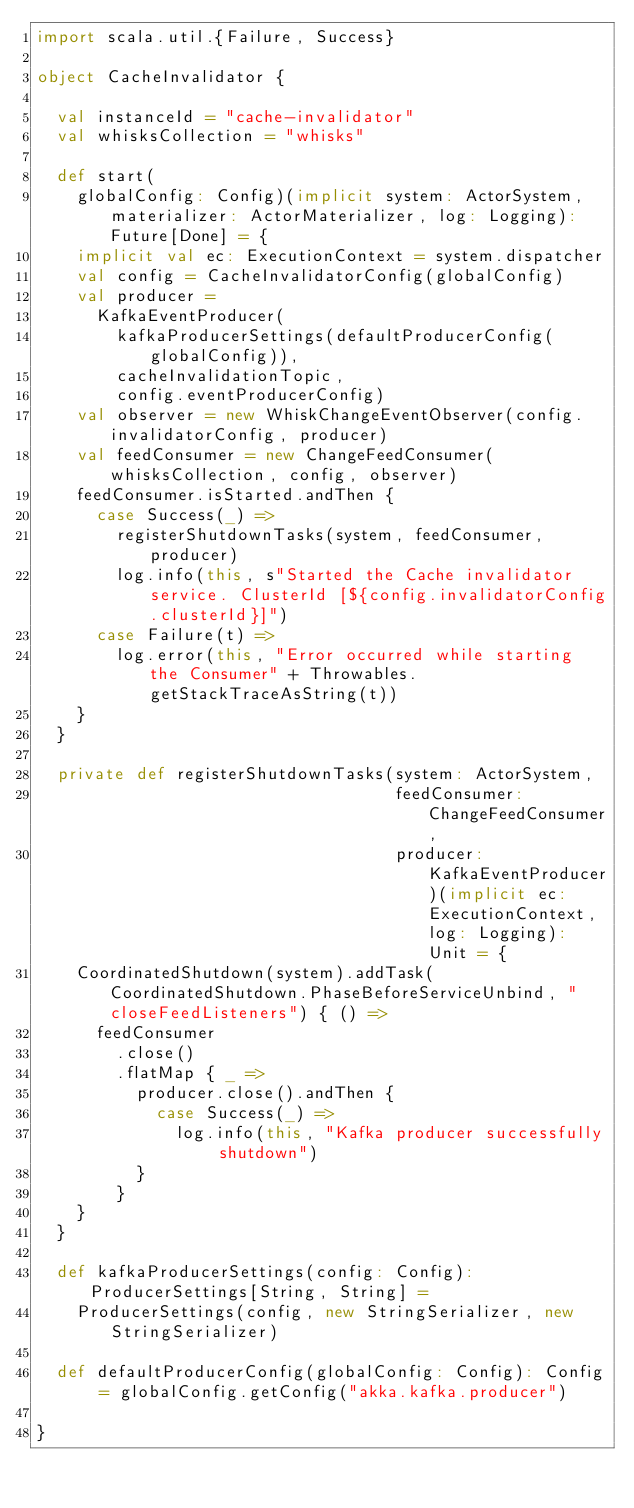Convert code to text. <code><loc_0><loc_0><loc_500><loc_500><_Scala_>import scala.util.{Failure, Success}

object CacheInvalidator {

  val instanceId = "cache-invalidator"
  val whisksCollection = "whisks"

  def start(
    globalConfig: Config)(implicit system: ActorSystem, materializer: ActorMaterializer, log: Logging): Future[Done] = {
    implicit val ec: ExecutionContext = system.dispatcher
    val config = CacheInvalidatorConfig(globalConfig)
    val producer =
      KafkaEventProducer(
        kafkaProducerSettings(defaultProducerConfig(globalConfig)),
        cacheInvalidationTopic,
        config.eventProducerConfig)
    val observer = new WhiskChangeEventObserver(config.invalidatorConfig, producer)
    val feedConsumer = new ChangeFeedConsumer(whisksCollection, config, observer)
    feedConsumer.isStarted.andThen {
      case Success(_) =>
        registerShutdownTasks(system, feedConsumer, producer)
        log.info(this, s"Started the Cache invalidator service. ClusterId [${config.invalidatorConfig.clusterId}]")
      case Failure(t) =>
        log.error(this, "Error occurred while starting the Consumer" + Throwables.getStackTraceAsString(t))
    }
  }

  private def registerShutdownTasks(system: ActorSystem,
                                    feedConsumer: ChangeFeedConsumer,
                                    producer: KafkaEventProducer)(implicit ec: ExecutionContext, log: Logging): Unit = {
    CoordinatedShutdown(system).addTask(CoordinatedShutdown.PhaseBeforeServiceUnbind, "closeFeedListeners") { () =>
      feedConsumer
        .close()
        .flatMap { _ =>
          producer.close().andThen {
            case Success(_) =>
              log.info(this, "Kafka producer successfully shutdown")
          }
        }
    }
  }

  def kafkaProducerSettings(config: Config): ProducerSettings[String, String] =
    ProducerSettings(config, new StringSerializer, new StringSerializer)

  def defaultProducerConfig(globalConfig: Config): Config = globalConfig.getConfig("akka.kafka.producer")

}
</code> 